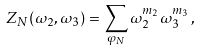Convert formula to latex. <formula><loc_0><loc_0><loc_500><loc_500>Z _ { N } ( \omega _ { 2 } , \omega _ { 3 } ) = \sum _ { \varphi _ { N } } \omega _ { 2 } ^ { m _ { 2 } } \omega _ { 3 } ^ { m _ { 3 } } \, ,</formula> 